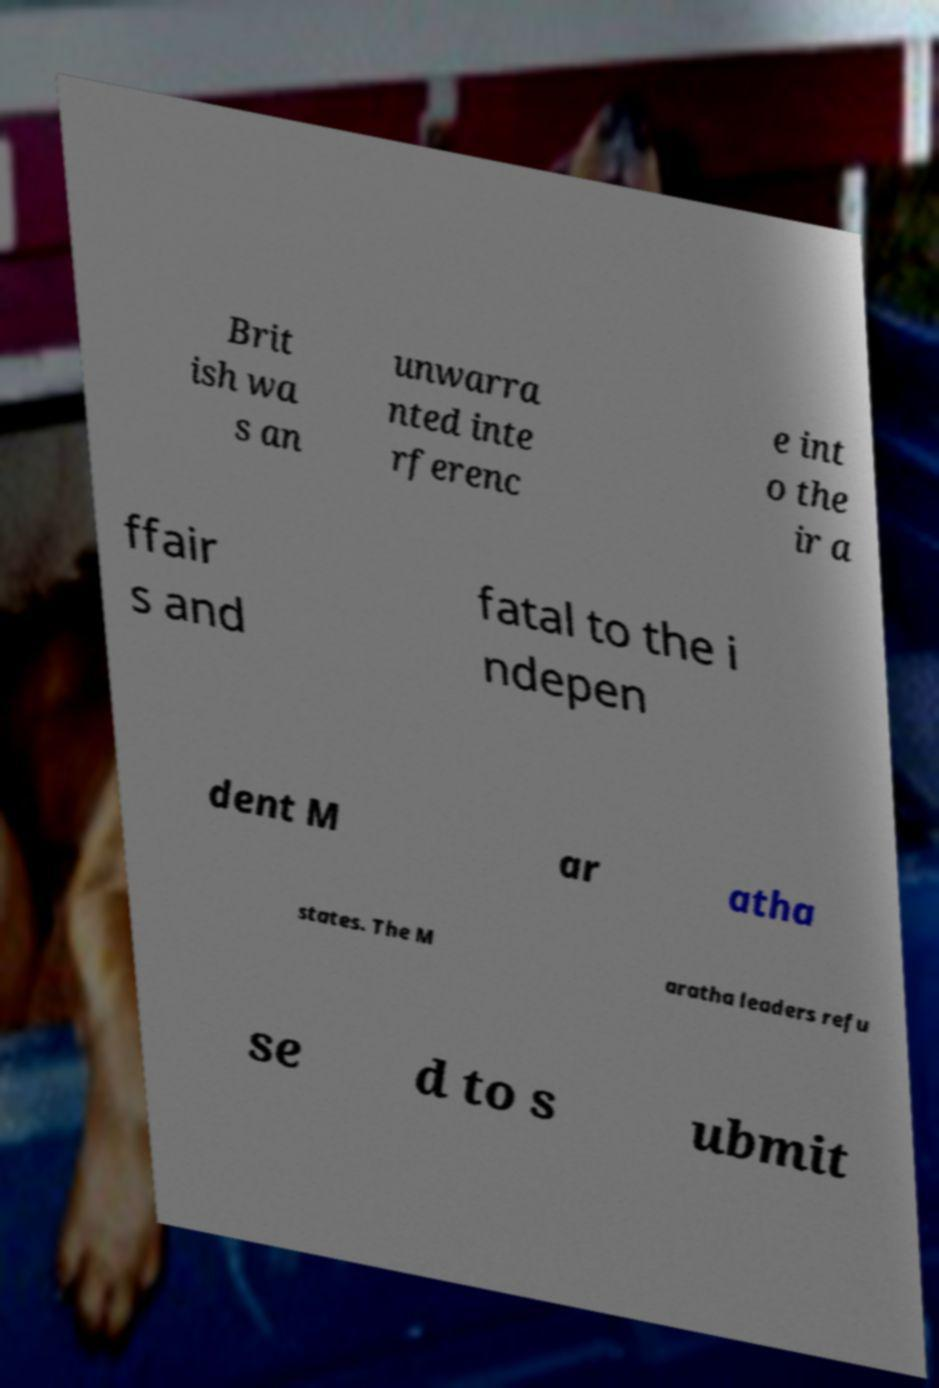Could you assist in decoding the text presented in this image and type it out clearly? Brit ish wa s an unwarra nted inte rferenc e int o the ir a ffair s and fatal to the i ndepen dent M ar atha states. The M aratha leaders refu se d to s ubmit 